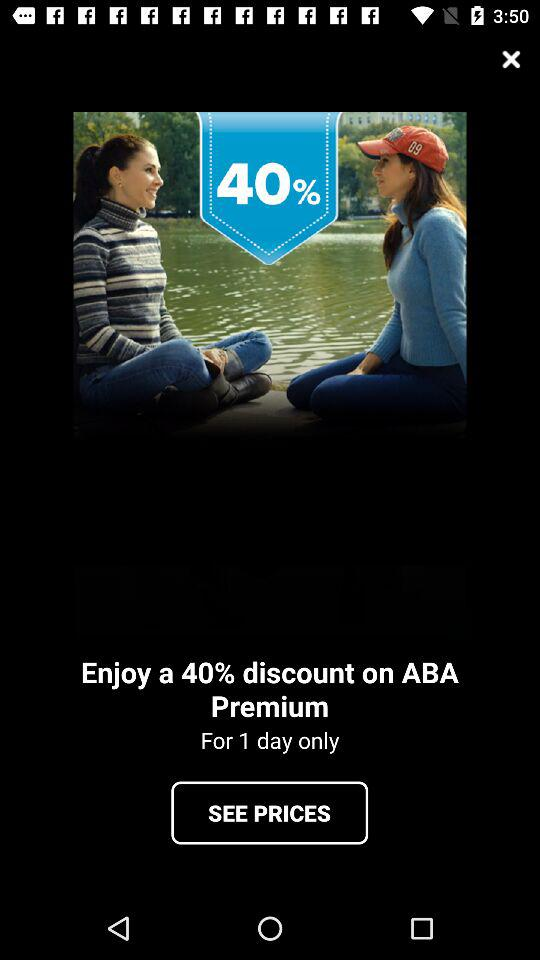How much will I save if I buy ABA Premium today?
Answer the question using a single word or phrase. 40% 